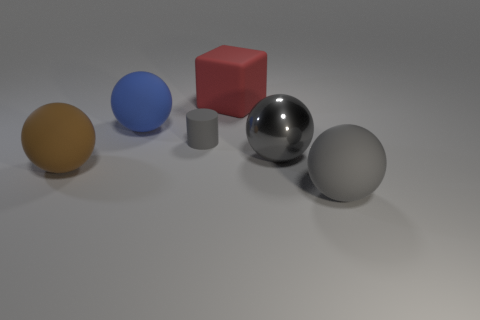Is the number of big gray matte balls that are behind the metal thing the same as the number of gray matte cylinders left of the big brown sphere?
Offer a very short reply. Yes. There is a large object on the right side of the gray sphere to the left of the gray matte object that is to the right of the gray matte cylinder; what shape is it?
Make the answer very short. Sphere. Is the red object that is left of the gray shiny object made of the same material as the big thing on the right side of the shiny ball?
Ensure brevity in your answer.  Yes. There is a big object behind the large blue object; what is its shape?
Offer a terse response. Cube. Is the number of small cyan metal cylinders less than the number of large gray metallic spheres?
Your response must be concise. Yes. Are there any large metal spheres behind the large gray sphere that is behind the object that is to the right of the gray shiny thing?
Give a very brief answer. No. What number of metallic objects are small gray cylinders or large red blocks?
Ensure brevity in your answer.  0. Is the small cylinder the same color as the metallic thing?
Provide a succinct answer. Yes. What number of gray matte things are in front of the gray metallic thing?
Your answer should be very brief. 1. How many rubber spheres are behind the gray rubber sphere and in front of the tiny object?
Your answer should be compact. 1. 